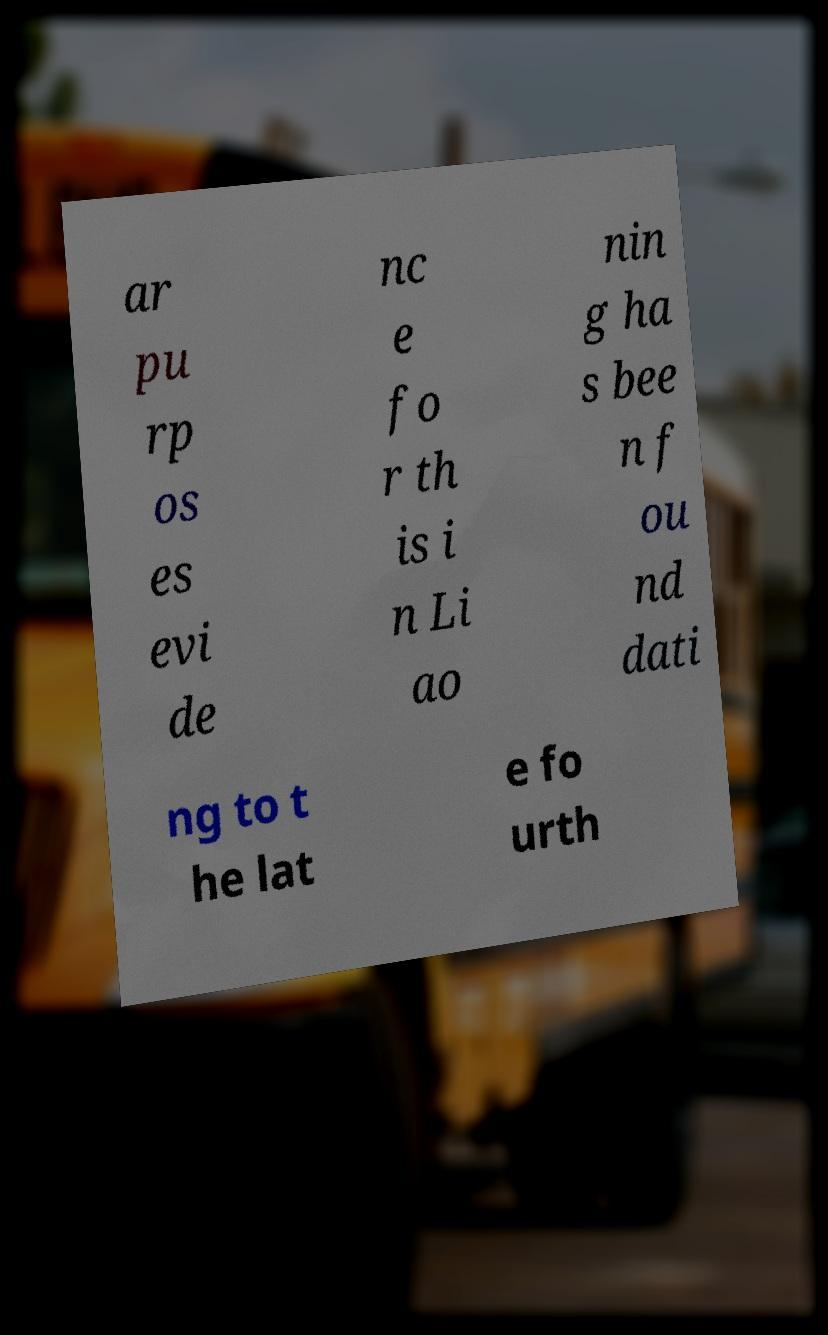What messages or text are displayed in this image? I need them in a readable, typed format. ar pu rp os es evi de nc e fo r th is i n Li ao nin g ha s bee n f ou nd dati ng to t he lat e fo urth 